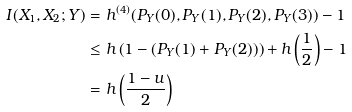Convert formula to latex. <formula><loc_0><loc_0><loc_500><loc_500>I ( X _ { 1 } , X _ { 2 } ; Y ) & = h ^ { ( 4 ) } ( P _ { Y } ( 0 ) , P _ { Y } ( 1 ) , P _ { Y } ( 2 ) , P _ { Y } ( 3 ) ) - 1 \\ & \leq h \left ( 1 - ( P _ { Y } ( 1 ) + P _ { Y } ( 2 ) ) \right ) + h \left ( \frac { 1 } { 2 } \right ) - 1 \\ & = h \left ( \frac { 1 - u } { 2 } \right )</formula> 